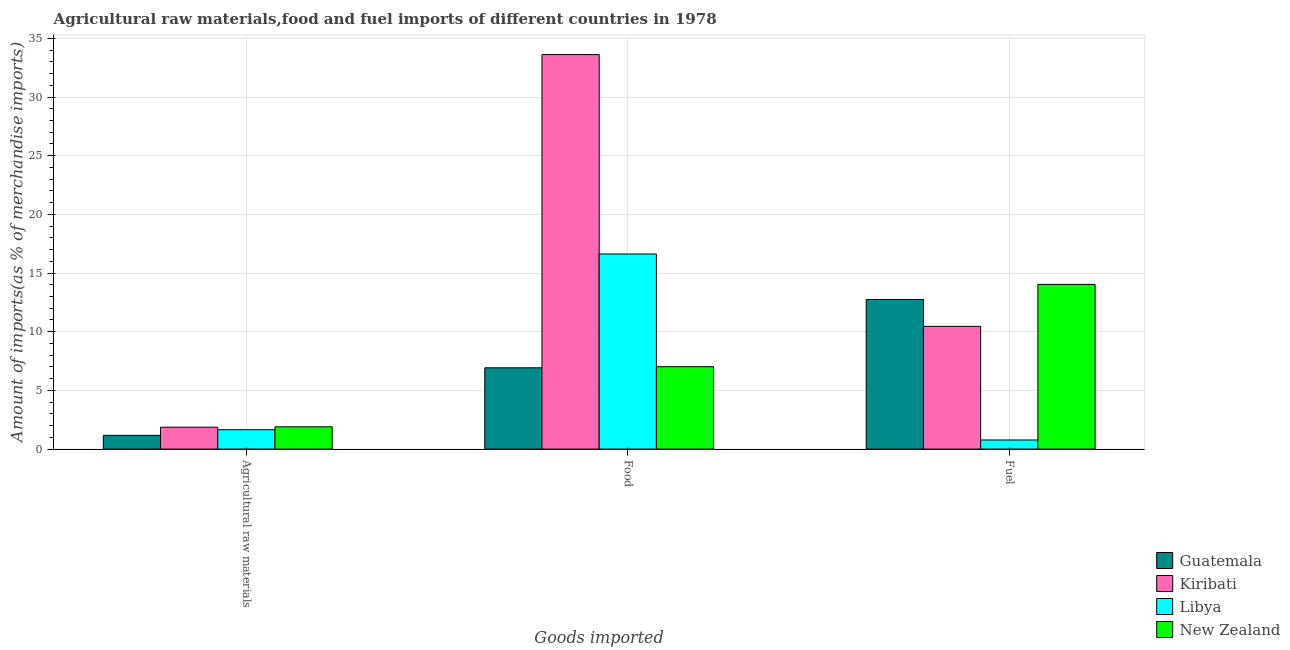How many different coloured bars are there?
Ensure brevity in your answer.  4. Are the number of bars on each tick of the X-axis equal?
Keep it short and to the point. Yes. How many bars are there on the 1st tick from the left?
Offer a terse response. 4. What is the label of the 3rd group of bars from the left?
Ensure brevity in your answer.  Fuel. What is the percentage of food imports in Kiribati?
Ensure brevity in your answer.  33.62. Across all countries, what is the maximum percentage of fuel imports?
Give a very brief answer. 14.03. Across all countries, what is the minimum percentage of raw materials imports?
Ensure brevity in your answer.  1.17. In which country was the percentage of food imports maximum?
Your answer should be very brief. Kiribati. In which country was the percentage of food imports minimum?
Offer a terse response. Guatemala. What is the total percentage of food imports in the graph?
Ensure brevity in your answer.  64.19. What is the difference between the percentage of food imports in Libya and that in Guatemala?
Your answer should be very brief. 9.7. What is the difference between the percentage of raw materials imports in Guatemala and the percentage of food imports in Libya?
Ensure brevity in your answer.  -15.45. What is the average percentage of raw materials imports per country?
Make the answer very short. 1.65. What is the difference between the percentage of fuel imports and percentage of food imports in Guatemala?
Offer a terse response. 5.82. What is the ratio of the percentage of food imports in Kiribati to that in New Zealand?
Keep it short and to the point. 4.79. What is the difference between the highest and the second highest percentage of raw materials imports?
Offer a terse response. 0.03. What is the difference between the highest and the lowest percentage of food imports?
Your answer should be compact. 26.69. In how many countries, is the percentage of raw materials imports greater than the average percentage of raw materials imports taken over all countries?
Give a very brief answer. 3. Is the sum of the percentage of fuel imports in Libya and Kiribati greater than the maximum percentage of food imports across all countries?
Make the answer very short. No. What does the 4th bar from the left in Fuel represents?
Offer a terse response. New Zealand. What does the 3rd bar from the right in Food represents?
Your answer should be compact. Kiribati. How many bars are there?
Offer a terse response. 12. Are all the bars in the graph horizontal?
Give a very brief answer. No. Are the values on the major ticks of Y-axis written in scientific E-notation?
Make the answer very short. No. Does the graph contain any zero values?
Provide a short and direct response. No. Does the graph contain grids?
Your answer should be very brief. Yes. What is the title of the graph?
Ensure brevity in your answer.  Agricultural raw materials,food and fuel imports of different countries in 1978. Does "Kuwait" appear as one of the legend labels in the graph?
Give a very brief answer. No. What is the label or title of the X-axis?
Offer a very short reply. Goods imported. What is the label or title of the Y-axis?
Offer a terse response. Amount of imports(as % of merchandise imports). What is the Amount of imports(as % of merchandise imports) of Guatemala in Agricultural raw materials?
Offer a terse response. 1.17. What is the Amount of imports(as % of merchandise imports) of Kiribati in Agricultural raw materials?
Keep it short and to the point. 1.86. What is the Amount of imports(as % of merchandise imports) of Libya in Agricultural raw materials?
Keep it short and to the point. 1.65. What is the Amount of imports(as % of merchandise imports) in New Zealand in Agricultural raw materials?
Make the answer very short. 1.9. What is the Amount of imports(as % of merchandise imports) of Guatemala in Food?
Your answer should be very brief. 6.93. What is the Amount of imports(as % of merchandise imports) of Kiribati in Food?
Offer a very short reply. 33.62. What is the Amount of imports(as % of merchandise imports) of Libya in Food?
Keep it short and to the point. 16.62. What is the Amount of imports(as % of merchandise imports) in New Zealand in Food?
Your response must be concise. 7.02. What is the Amount of imports(as % of merchandise imports) of Guatemala in Fuel?
Provide a succinct answer. 12.75. What is the Amount of imports(as % of merchandise imports) of Kiribati in Fuel?
Offer a very short reply. 10.46. What is the Amount of imports(as % of merchandise imports) in Libya in Fuel?
Your answer should be very brief. 0.78. What is the Amount of imports(as % of merchandise imports) of New Zealand in Fuel?
Provide a short and direct response. 14.03. Across all Goods imported, what is the maximum Amount of imports(as % of merchandise imports) in Guatemala?
Your answer should be compact. 12.75. Across all Goods imported, what is the maximum Amount of imports(as % of merchandise imports) of Kiribati?
Offer a very short reply. 33.62. Across all Goods imported, what is the maximum Amount of imports(as % of merchandise imports) of Libya?
Your response must be concise. 16.62. Across all Goods imported, what is the maximum Amount of imports(as % of merchandise imports) in New Zealand?
Your answer should be very brief. 14.03. Across all Goods imported, what is the minimum Amount of imports(as % of merchandise imports) of Guatemala?
Ensure brevity in your answer.  1.17. Across all Goods imported, what is the minimum Amount of imports(as % of merchandise imports) in Kiribati?
Offer a terse response. 1.86. Across all Goods imported, what is the minimum Amount of imports(as % of merchandise imports) in Libya?
Offer a terse response. 0.78. Across all Goods imported, what is the minimum Amount of imports(as % of merchandise imports) in New Zealand?
Your response must be concise. 1.9. What is the total Amount of imports(as % of merchandise imports) of Guatemala in the graph?
Give a very brief answer. 20.84. What is the total Amount of imports(as % of merchandise imports) in Kiribati in the graph?
Ensure brevity in your answer.  45.94. What is the total Amount of imports(as % of merchandise imports) in Libya in the graph?
Your answer should be very brief. 19.05. What is the total Amount of imports(as % of merchandise imports) in New Zealand in the graph?
Offer a terse response. 22.95. What is the difference between the Amount of imports(as % of merchandise imports) of Guatemala in Agricultural raw materials and that in Food?
Your answer should be very brief. -5.76. What is the difference between the Amount of imports(as % of merchandise imports) of Kiribati in Agricultural raw materials and that in Food?
Keep it short and to the point. -31.75. What is the difference between the Amount of imports(as % of merchandise imports) in Libya in Agricultural raw materials and that in Food?
Offer a terse response. -14.97. What is the difference between the Amount of imports(as % of merchandise imports) in New Zealand in Agricultural raw materials and that in Food?
Make the answer very short. -5.12. What is the difference between the Amount of imports(as % of merchandise imports) of Guatemala in Agricultural raw materials and that in Fuel?
Give a very brief answer. -11.58. What is the difference between the Amount of imports(as % of merchandise imports) of Kiribati in Agricultural raw materials and that in Fuel?
Provide a succinct answer. -8.59. What is the difference between the Amount of imports(as % of merchandise imports) in Libya in Agricultural raw materials and that in Fuel?
Ensure brevity in your answer.  0.88. What is the difference between the Amount of imports(as % of merchandise imports) of New Zealand in Agricultural raw materials and that in Fuel?
Ensure brevity in your answer.  -12.14. What is the difference between the Amount of imports(as % of merchandise imports) in Guatemala in Food and that in Fuel?
Keep it short and to the point. -5.82. What is the difference between the Amount of imports(as % of merchandise imports) of Kiribati in Food and that in Fuel?
Your response must be concise. 23.16. What is the difference between the Amount of imports(as % of merchandise imports) of Libya in Food and that in Fuel?
Provide a short and direct response. 15.85. What is the difference between the Amount of imports(as % of merchandise imports) in New Zealand in Food and that in Fuel?
Your answer should be compact. -7.01. What is the difference between the Amount of imports(as % of merchandise imports) in Guatemala in Agricultural raw materials and the Amount of imports(as % of merchandise imports) in Kiribati in Food?
Provide a short and direct response. -32.45. What is the difference between the Amount of imports(as % of merchandise imports) of Guatemala in Agricultural raw materials and the Amount of imports(as % of merchandise imports) of Libya in Food?
Keep it short and to the point. -15.45. What is the difference between the Amount of imports(as % of merchandise imports) of Guatemala in Agricultural raw materials and the Amount of imports(as % of merchandise imports) of New Zealand in Food?
Provide a short and direct response. -5.85. What is the difference between the Amount of imports(as % of merchandise imports) of Kiribati in Agricultural raw materials and the Amount of imports(as % of merchandise imports) of Libya in Food?
Make the answer very short. -14.76. What is the difference between the Amount of imports(as % of merchandise imports) of Kiribati in Agricultural raw materials and the Amount of imports(as % of merchandise imports) of New Zealand in Food?
Provide a succinct answer. -5.16. What is the difference between the Amount of imports(as % of merchandise imports) in Libya in Agricultural raw materials and the Amount of imports(as % of merchandise imports) in New Zealand in Food?
Your answer should be very brief. -5.37. What is the difference between the Amount of imports(as % of merchandise imports) in Guatemala in Agricultural raw materials and the Amount of imports(as % of merchandise imports) in Kiribati in Fuel?
Provide a succinct answer. -9.29. What is the difference between the Amount of imports(as % of merchandise imports) in Guatemala in Agricultural raw materials and the Amount of imports(as % of merchandise imports) in Libya in Fuel?
Ensure brevity in your answer.  0.39. What is the difference between the Amount of imports(as % of merchandise imports) of Guatemala in Agricultural raw materials and the Amount of imports(as % of merchandise imports) of New Zealand in Fuel?
Make the answer very short. -12.87. What is the difference between the Amount of imports(as % of merchandise imports) in Kiribati in Agricultural raw materials and the Amount of imports(as % of merchandise imports) in Libya in Fuel?
Offer a very short reply. 1.09. What is the difference between the Amount of imports(as % of merchandise imports) of Kiribati in Agricultural raw materials and the Amount of imports(as % of merchandise imports) of New Zealand in Fuel?
Make the answer very short. -12.17. What is the difference between the Amount of imports(as % of merchandise imports) of Libya in Agricultural raw materials and the Amount of imports(as % of merchandise imports) of New Zealand in Fuel?
Your response must be concise. -12.38. What is the difference between the Amount of imports(as % of merchandise imports) of Guatemala in Food and the Amount of imports(as % of merchandise imports) of Kiribati in Fuel?
Offer a very short reply. -3.53. What is the difference between the Amount of imports(as % of merchandise imports) of Guatemala in Food and the Amount of imports(as % of merchandise imports) of Libya in Fuel?
Offer a very short reply. 6.15. What is the difference between the Amount of imports(as % of merchandise imports) of Guatemala in Food and the Amount of imports(as % of merchandise imports) of New Zealand in Fuel?
Provide a succinct answer. -7.11. What is the difference between the Amount of imports(as % of merchandise imports) of Kiribati in Food and the Amount of imports(as % of merchandise imports) of Libya in Fuel?
Offer a very short reply. 32.84. What is the difference between the Amount of imports(as % of merchandise imports) in Kiribati in Food and the Amount of imports(as % of merchandise imports) in New Zealand in Fuel?
Your answer should be very brief. 19.58. What is the difference between the Amount of imports(as % of merchandise imports) of Libya in Food and the Amount of imports(as % of merchandise imports) of New Zealand in Fuel?
Your response must be concise. 2.59. What is the average Amount of imports(as % of merchandise imports) of Guatemala per Goods imported?
Provide a succinct answer. 6.95. What is the average Amount of imports(as % of merchandise imports) of Kiribati per Goods imported?
Provide a succinct answer. 15.31. What is the average Amount of imports(as % of merchandise imports) in Libya per Goods imported?
Offer a very short reply. 6.35. What is the average Amount of imports(as % of merchandise imports) of New Zealand per Goods imported?
Your answer should be compact. 7.65. What is the difference between the Amount of imports(as % of merchandise imports) in Guatemala and Amount of imports(as % of merchandise imports) in Kiribati in Agricultural raw materials?
Your answer should be compact. -0.7. What is the difference between the Amount of imports(as % of merchandise imports) in Guatemala and Amount of imports(as % of merchandise imports) in Libya in Agricultural raw materials?
Your answer should be very brief. -0.48. What is the difference between the Amount of imports(as % of merchandise imports) in Guatemala and Amount of imports(as % of merchandise imports) in New Zealand in Agricultural raw materials?
Your response must be concise. -0.73. What is the difference between the Amount of imports(as % of merchandise imports) of Kiribati and Amount of imports(as % of merchandise imports) of Libya in Agricultural raw materials?
Your response must be concise. 0.21. What is the difference between the Amount of imports(as % of merchandise imports) of Kiribati and Amount of imports(as % of merchandise imports) of New Zealand in Agricultural raw materials?
Your answer should be compact. -0.03. What is the difference between the Amount of imports(as % of merchandise imports) in Libya and Amount of imports(as % of merchandise imports) in New Zealand in Agricultural raw materials?
Ensure brevity in your answer.  -0.25. What is the difference between the Amount of imports(as % of merchandise imports) of Guatemala and Amount of imports(as % of merchandise imports) of Kiribati in Food?
Your response must be concise. -26.69. What is the difference between the Amount of imports(as % of merchandise imports) of Guatemala and Amount of imports(as % of merchandise imports) of Libya in Food?
Provide a short and direct response. -9.7. What is the difference between the Amount of imports(as % of merchandise imports) in Guatemala and Amount of imports(as % of merchandise imports) in New Zealand in Food?
Your response must be concise. -0.09. What is the difference between the Amount of imports(as % of merchandise imports) of Kiribati and Amount of imports(as % of merchandise imports) of Libya in Food?
Offer a terse response. 16.99. What is the difference between the Amount of imports(as % of merchandise imports) of Kiribati and Amount of imports(as % of merchandise imports) of New Zealand in Food?
Provide a succinct answer. 26.59. What is the difference between the Amount of imports(as % of merchandise imports) of Libya and Amount of imports(as % of merchandise imports) of New Zealand in Food?
Provide a succinct answer. 9.6. What is the difference between the Amount of imports(as % of merchandise imports) in Guatemala and Amount of imports(as % of merchandise imports) in Kiribati in Fuel?
Keep it short and to the point. 2.29. What is the difference between the Amount of imports(as % of merchandise imports) in Guatemala and Amount of imports(as % of merchandise imports) in Libya in Fuel?
Ensure brevity in your answer.  11.97. What is the difference between the Amount of imports(as % of merchandise imports) in Guatemala and Amount of imports(as % of merchandise imports) in New Zealand in Fuel?
Offer a very short reply. -1.29. What is the difference between the Amount of imports(as % of merchandise imports) in Kiribati and Amount of imports(as % of merchandise imports) in Libya in Fuel?
Provide a short and direct response. 9.68. What is the difference between the Amount of imports(as % of merchandise imports) in Kiribati and Amount of imports(as % of merchandise imports) in New Zealand in Fuel?
Make the answer very short. -3.58. What is the difference between the Amount of imports(as % of merchandise imports) in Libya and Amount of imports(as % of merchandise imports) in New Zealand in Fuel?
Make the answer very short. -13.26. What is the ratio of the Amount of imports(as % of merchandise imports) in Guatemala in Agricultural raw materials to that in Food?
Give a very brief answer. 0.17. What is the ratio of the Amount of imports(as % of merchandise imports) in Kiribati in Agricultural raw materials to that in Food?
Keep it short and to the point. 0.06. What is the ratio of the Amount of imports(as % of merchandise imports) of Libya in Agricultural raw materials to that in Food?
Your answer should be very brief. 0.1. What is the ratio of the Amount of imports(as % of merchandise imports) of New Zealand in Agricultural raw materials to that in Food?
Keep it short and to the point. 0.27. What is the ratio of the Amount of imports(as % of merchandise imports) of Guatemala in Agricultural raw materials to that in Fuel?
Provide a short and direct response. 0.09. What is the ratio of the Amount of imports(as % of merchandise imports) of Kiribati in Agricultural raw materials to that in Fuel?
Provide a succinct answer. 0.18. What is the ratio of the Amount of imports(as % of merchandise imports) of Libya in Agricultural raw materials to that in Fuel?
Provide a short and direct response. 2.13. What is the ratio of the Amount of imports(as % of merchandise imports) of New Zealand in Agricultural raw materials to that in Fuel?
Ensure brevity in your answer.  0.14. What is the ratio of the Amount of imports(as % of merchandise imports) of Guatemala in Food to that in Fuel?
Your answer should be very brief. 0.54. What is the ratio of the Amount of imports(as % of merchandise imports) in Kiribati in Food to that in Fuel?
Ensure brevity in your answer.  3.21. What is the ratio of the Amount of imports(as % of merchandise imports) of Libya in Food to that in Fuel?
Offer a very short reply. 21.44. What is the ratio of the Amount of imports(as % of merchandise imports) in New Zealand in Food to that in Fuel?
Ensure brevity in your answer.  0.5. What is the difference between the highest and the second highest Amount of imports(as % of merchandise imports) of Guatemala?
Keep it short and to the point. 5.82. What is the difference between the highest and the second highest Amount of imports(as % of merchandise imports) of Kiribati?
Your answer should be very brief. 23.16. What is the difference between the highest and the second highest Amount of imports(as % of merchandise imports) in Libya?
Ensure brevity in your answer.  14.97. What is the difference between the highest and the second highest Amount of imports(as % of merchandise imports) in New Zealand?
Keep it short and to the point. 7.01. What is the difference between the highest and the lowest Amount of imports(as % of merchandise imports) in Guatemala?
Provide a short and direct response. 11.58. What is the difference between the highest and the lowest Amount of imports(as % of merchandise imports) in Kiribati?
Ensure brevity in your answer.  31.75. What is the difference between the highest and the lowest Amount of imports(as % of merchandise imports) in Libya?
Offer a very short reply. 15.85. What is the difference between the highest and the lowest Amount of imports(as % of merchandise imports) in New Zealand?
Ensure brevity in your answer.  12.14. 